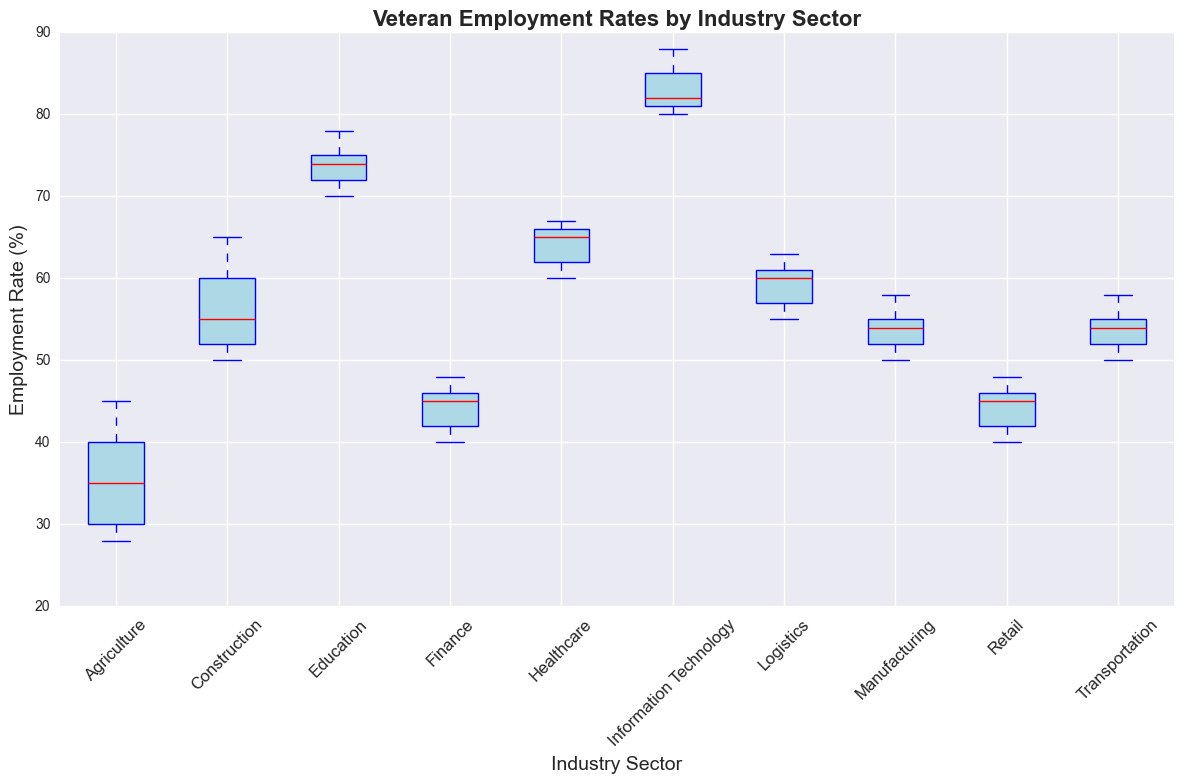Which industry sector has the highest median employment rate for veterans? Look at the red lines indicating the median values in each box of the sectors. The highest red line is in the "Information Technology" sector.
Answer: Information Technology What is the median employment rate for veterans in the Healthcare sector? Locate the red line inside the box for the "Healthcare" sector. The position of this line indicates the median employment rate.
Answer: 66 Which industry sectors have a median employment rate below 50%? Look at the red lines indicating median values in each box. Sectors with medians below the 50% mark are "Agriculture," "Finance," and "Retail".
Answer: Agriculture, Finance, Retail Is the range (difference between the maximum and minimum) of employment rates larger in the Construction sector or the Transportation sector? Identify the top and bottom lines of the boxes, which represent the maximum and minimum rates, respectively. For Construction, the maximum is 65 and the minimum is 50, giving a range of 15. For Transportation, the maximum is 58 and the minimum is 50, giving a range of 8.
Answer: Construction What is the interquartile range (IQR) of the employment rates in the Education sector? The IQR is calculated as the difference between the third quartile (75th percentile, the top of the box) and the first quartile (25th percentile, the bottom of the box). For Education, the top of the box is at 74 and the bottom is at 70. Therefore, the IQR is 74 - 70 = 4.
Answer: 4 Which industry sector shows the least variability in employment rates (i.e., smallest interquartile range)? Identify the height of the boxes (IQR) for each sector. The sector with the smallest box height indicates the least variability. The "Agriculture" sector has the smallest IQR.
Answer: Agriculture In which industry sector do veterans have the widest distribution of employment rates? The widest distribution can be identified by the length of the whiskers, which indicate the spread of the data. The "Information Technology" sector has the whiskers spread out further compared to others.
Answer: Information Technology Are the employment rates for veterans in the Logistics sector more concentrated around the median compared to the Construction sector? Compare the sizes of the boxes in the Logistics and Construction sectors. A smaller box indicates values are more concentrated around the median. The box for the Logistics sector is smaller than that for the Construction sector.
Answer: Yes 